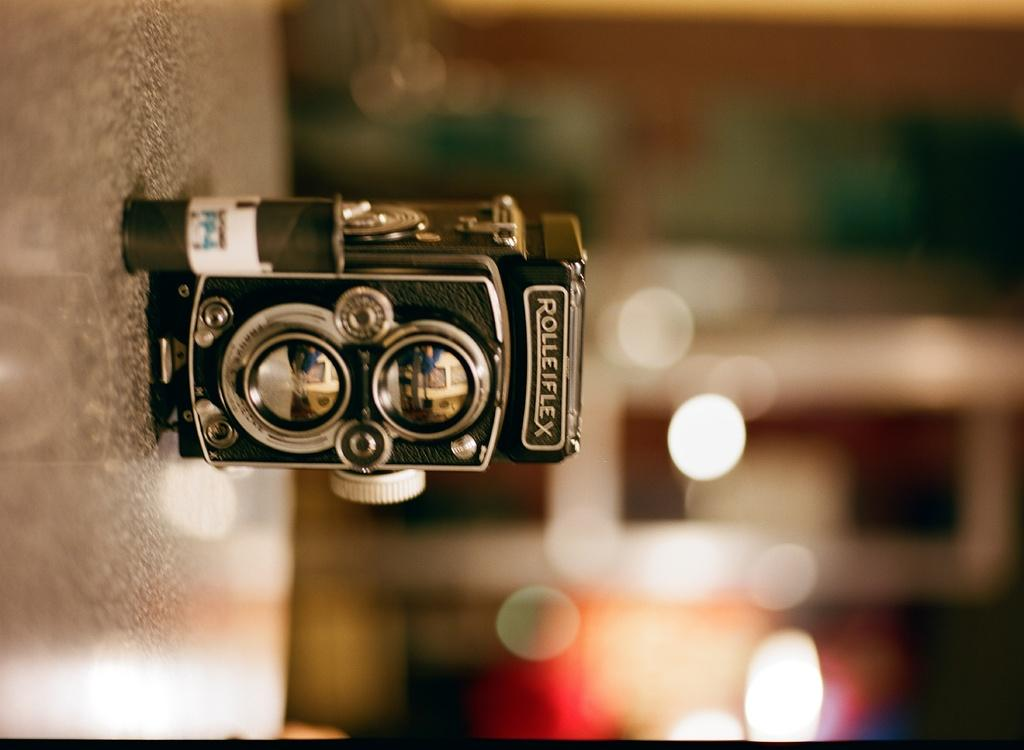What object is the main subject of the picture? The main subject of the picture is a camera. How is the camera positioned in the image? The camera is placed on a surface. What part of the camera is visible in the image? The back side of the camera is visible. What can be seen on the back side of the camera? Light focuses are visible on the back side of the camera. What type of pigs can be seen distributing a sense of joy in the image? There are no pigs present in the image, nor is there any indication of a sense of joy being distributed. 